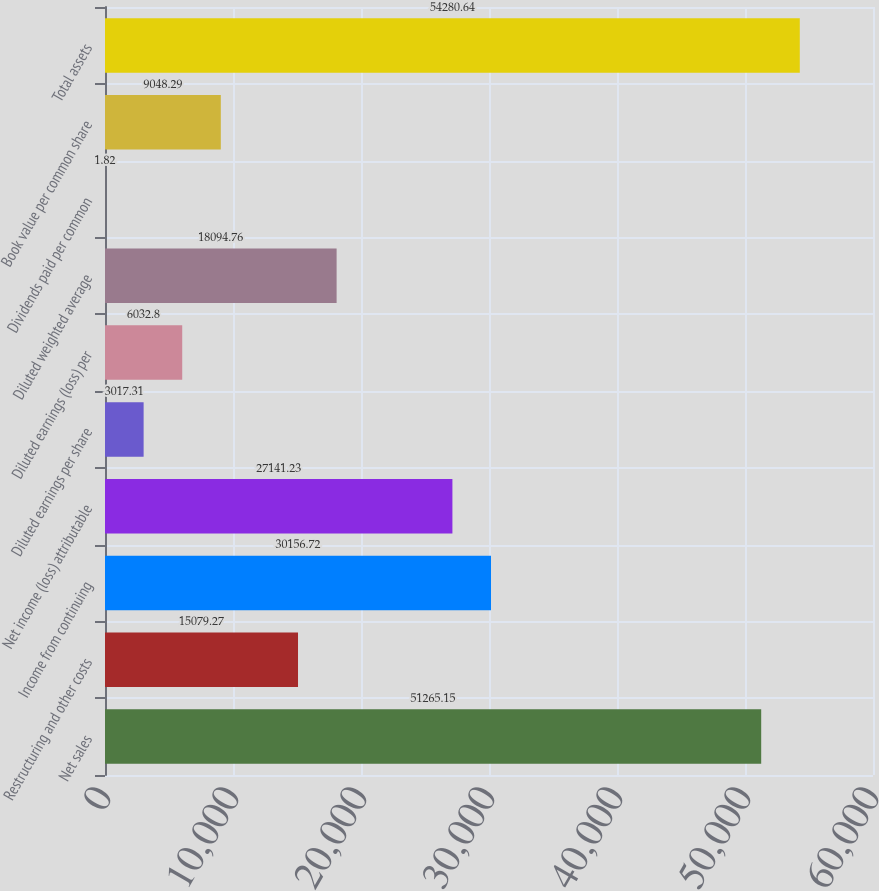Convert chart. <chart><loc_0><loc_0><loc_500><loc_500><bar_chart><fcel>Net sales<fcel>Restructuring and other costs<fcel>Income from continuing<fcel>Net income (loss) attributable<fcel>Diluted earnings per share<fcel>Diluted earnings (loss) per<fcel>Diluted weighted average<fcel>Dividends paid per common<fcel>Book value per common share<fcel>Total assets<nl><fcel>51265.2<fcel>15079.3<fcel>30156.7<fcel>27141.2<fcel>3017.31<fcel>6032.8<fcel>18094.8<fcel>1.82<fcel>9048.29<fcel>54280.6<nl></chart> 